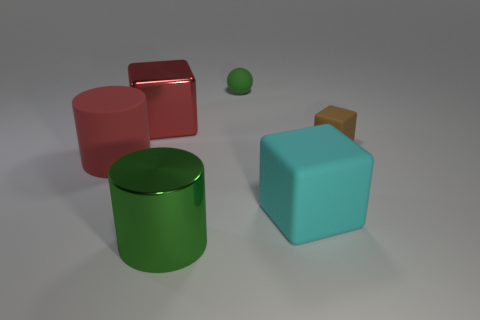What is the color of the other large thing that is the same shape as the cyan thing?
Provide a succinct answer. Red. Do the tiny brown rubber thing and the big metal thing that is behind the red cylinder have the same shape?
Your answer should be compact. Yes. How many things are matte blocks behind the large red matte cylinder or large things to the left of the small sphere?
Offer a very short reply. 4. Is the number of brown rubber objects that are behind the tiny cube less than the number of large green cylinders?
Ensure brevity in your answer.  Yes. Do the large cyan object and the big thing behind the red matte thing have the same material?
Offer a very short reply. No. What material is the big cyan cube?
Your answer should be compact. Rubber. What is the material of the red object in front of the block that is to the left of the cube in front of the big red cylinder?
Make the answer very short. Rubber. There is a large metal cylinder; is its color the same as the rubber block that is in front of the tiny brown rubber block?
Give a very brief answer. No. Is there anything else that has the same shape as the large cyan rubber object?
Offer a very short reply. Yes. The metallic object that is on the left side of the green object that is in front of the tiny matte sphere is what color?
Give a very brief answer. Red. 